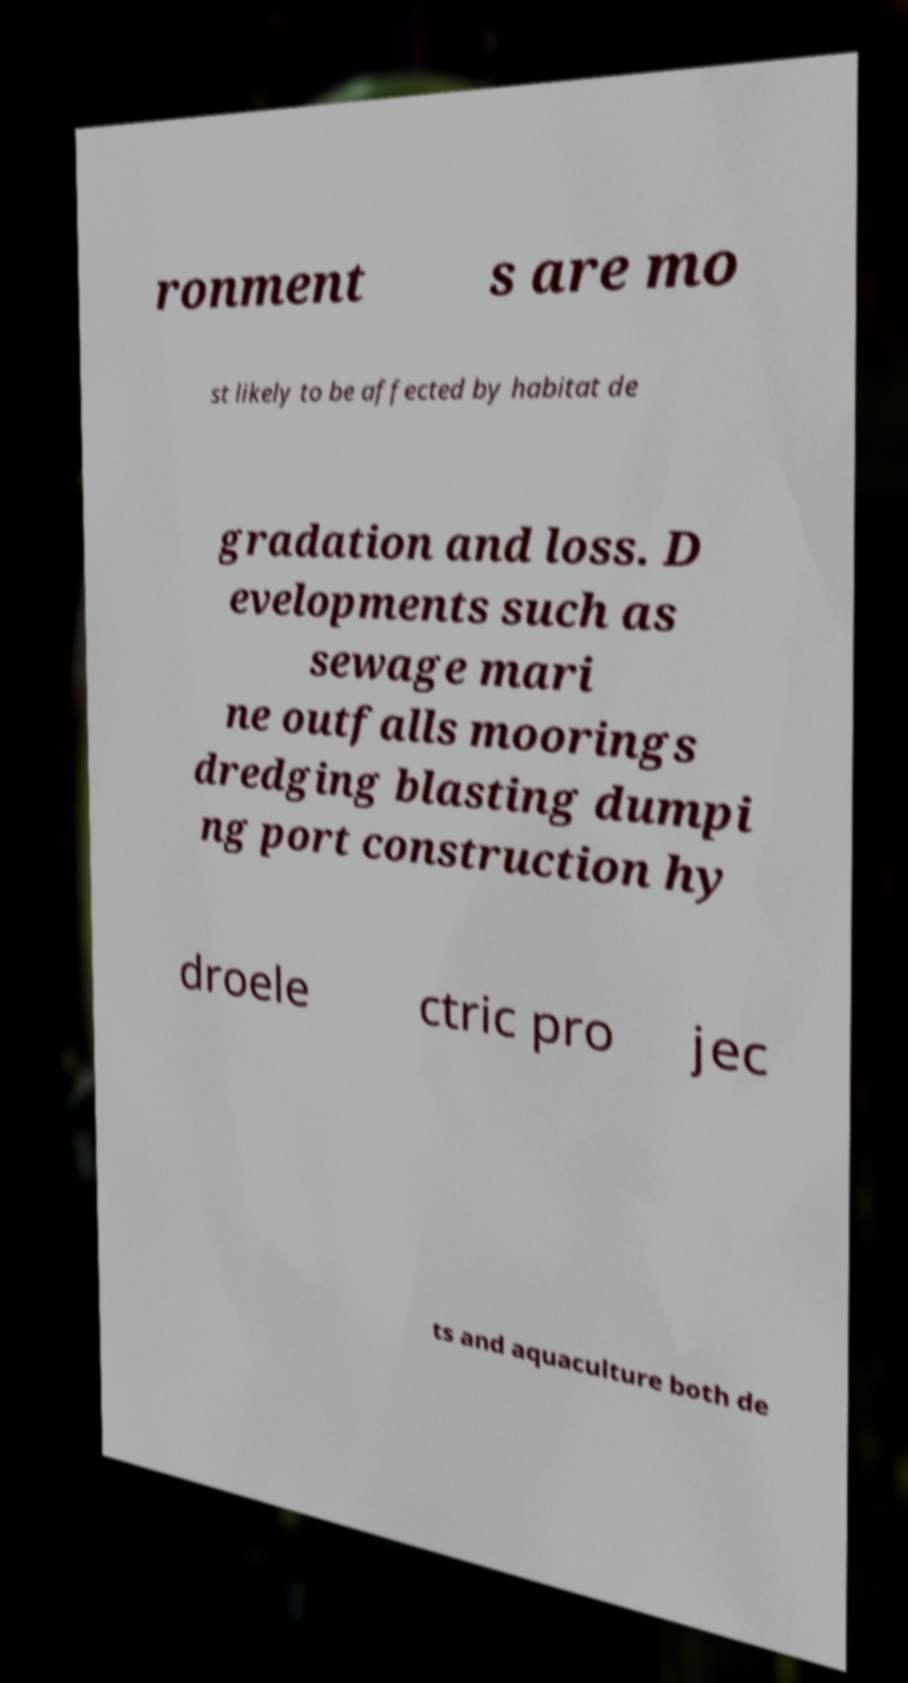Could you extract and type out the text from this image? ronment s are mo st likely to be affected by habitat de gradation and loss. D evelopments such as sewage mari ne outfalls moorings dredging blasting dumpi ng port construction hy droele ctric pro jec ts and aquaculture both de 